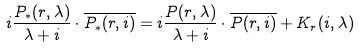<formula> <loc_0><loc_0><loc_500><loc_500>i \frac { P _ { * } ( r , \lambda ) } { \lambda + i } \cdot \overline { P _ { * } ( r , i ) } = i \frac { P ( r , \lambda ) } { \lambda + i } \cdot \overline { P ( r , i ) } + K _ { r } ( i , \lambda )</formula> 